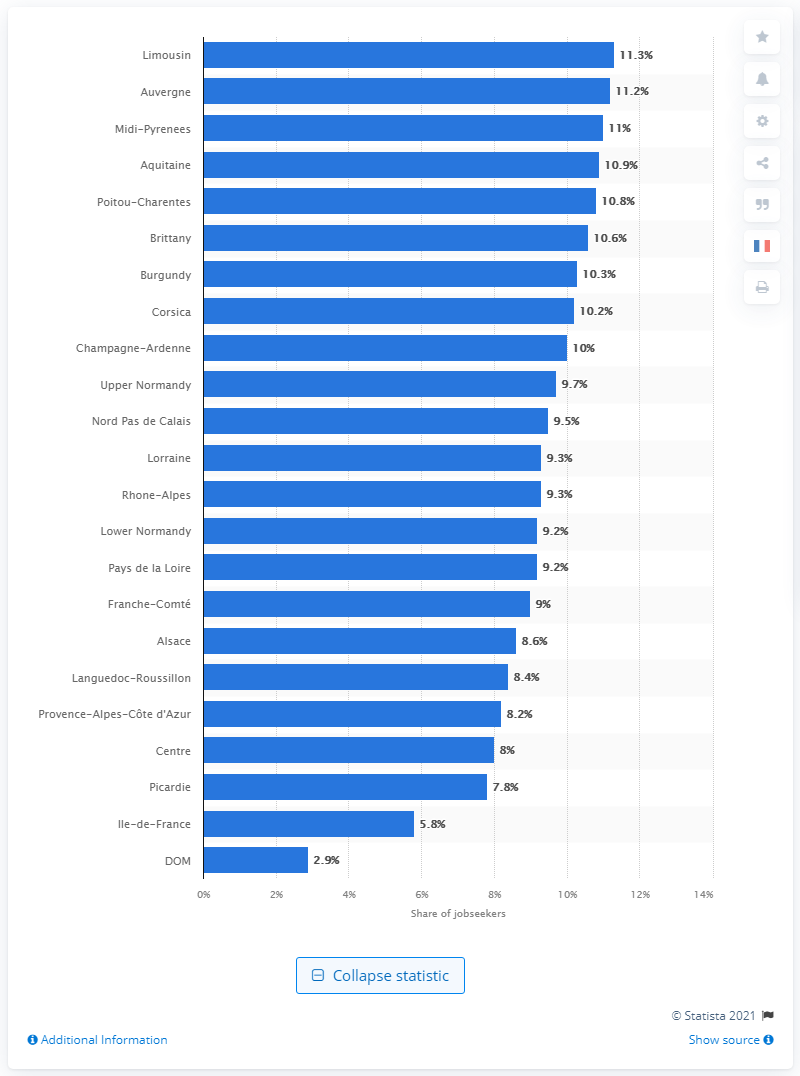Draw attention to some important aspects in this diagram. In the Midi-Pyrénées region, 11% of job seekers identified as having a disability. 